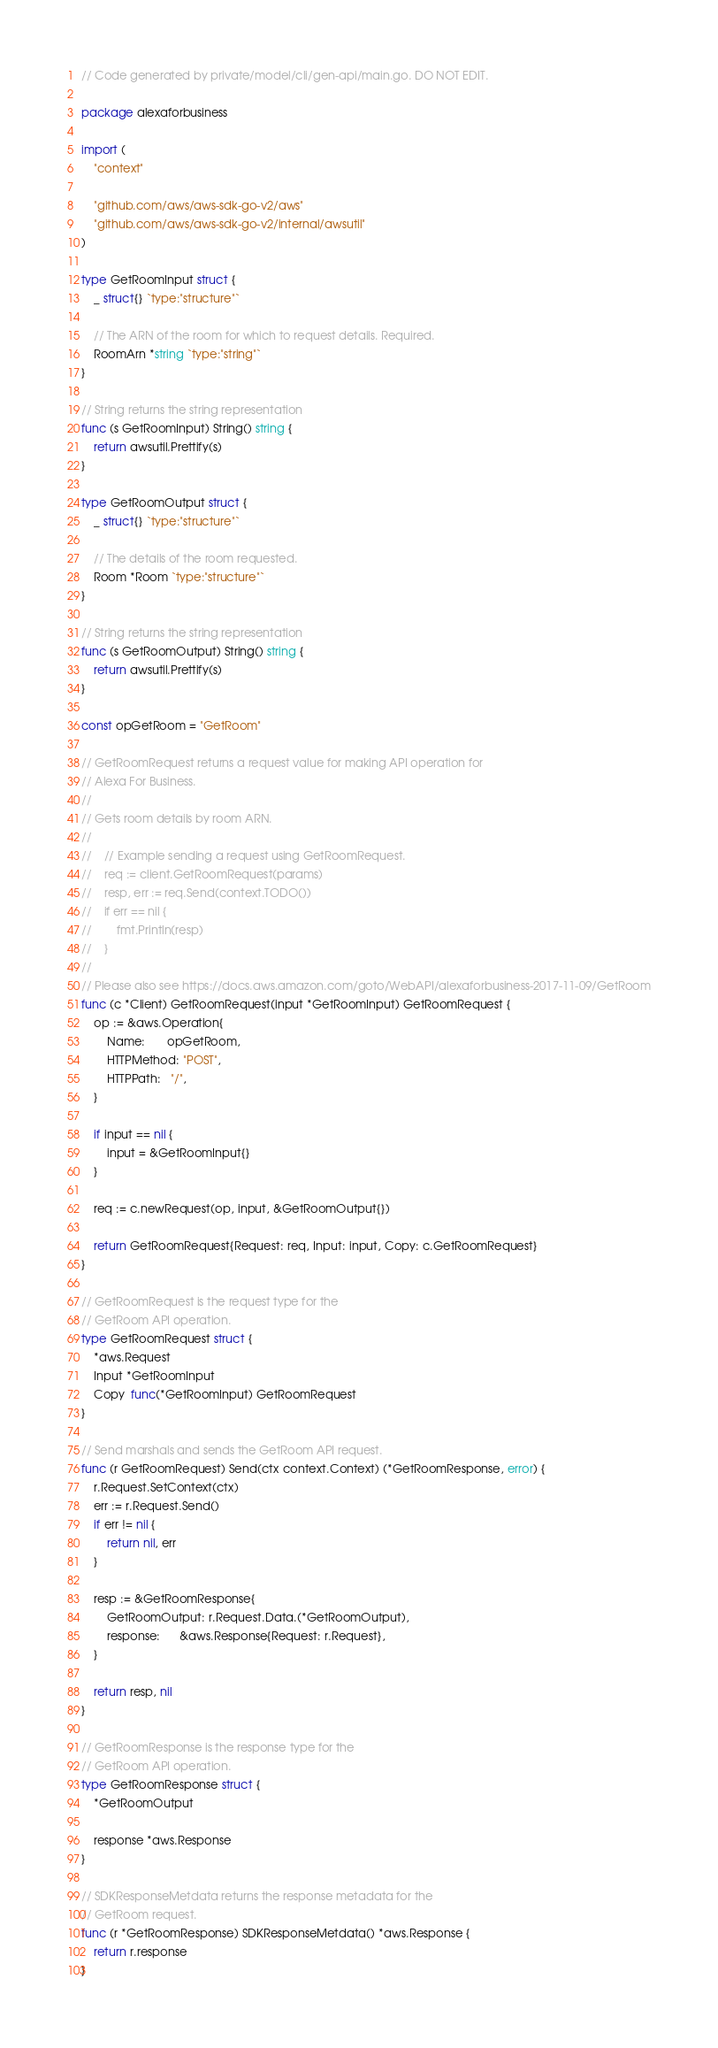Convert code to text. <code><loc_0><loc_0><loc_500><loc_500><_Go_>// Code generated by private/model/cli/gen-api/main.go. DO NOT EDIT.

package alexaforbusiness

import (
	"context"

	"github.com/aws/aws-sdk-go-v2/aws"
	"github.com/aws/aws-sdk-go-v2/internal/awsutil"
)

type GetRoomInput struct {
	_ struct{} `type:"structure"`

	// The ARN of the room for which to request details. Required.
	RoomArn *string `type:"string"`
}

// String returns the string representation
func (s GetRoomInput) String() string {
	return awsutil.Prettify(s)
}

type GetRoomOutput struct {
	_ struct{} `type:"structure"`

	// The details of the room requested.
	Room *Room `type:"structure"`
}

// String returns the string representation
func (s GetRoomOutput) String() string {
	return awsutil.Prettify(s)
}

const opGetRoom = "GetRoom"

// GetRoomRequest returns a request value for making API operation for
// Alexa For Business.
//
// Gets room details by room ARN.
//
//    // Example sending a request using GetRoomRequest.
//    req := client.GetRoomRequest(params)
//    resp, err := req.Send(context.TODO())
//    if err == nil {
//        fmt.Println(resp)
//    }
//
// Please also see https://docs.aws.amazon.com/goto/WebAPI/alexaforbusiness-2017-11-09/GetRoom
func (c *Client) GetRoomRequest(input *GetRoomInput) GetRoomRequest {
	op := &aws.Operation{
		Name:       opGetRoom,
		HTTPMethod: "POST",
		HTTPPath:   "/",
	}

	if input == nil {
		input = &GetRoomInput{}
	}

	req := c.newRequest(op, input, &GetRoomOutput{})

	return GetRoomRequest{Request: req, Input: input, Copy: c.GetRoomRequest}
}

// GetRoomRequest is the request type for the
// GetRoom API operation.
type GetRoomRequest struct {
	*aws.Request
	Input *GetRoomInput
	Copy  func(*GetRoomInput) GetRoomRequest
}

// Send marshals and sends the GetRoom API request.
func (r GetRoomRequest) Send(ctx context.Context) (*GetRoomResponse, error) {
	r.Request.SetContext(ctx)
	err := r.Request.Send()
	if err != nil {
		return nil, err
	}

	resp := &GetRoomResponse{
		GetRoomOutput: r.Request.Data.(*GetRoomOutput),
		response:      &aws.Response{Request: r.Request},
	}

	return resp, nil
}

// GetRoomResponse is the response type for the
// GetRoom API operation.
type GetRoomResponse struct {
	*GetRoomOutput

	response *aws.Response
}

// SDKResponseMetdata returns the response metadata for the
// GetRoom request.
func (r *GetRoomResponse) SDKResponseMetdata() *aws.Response {
	return r.response
}
</code> 